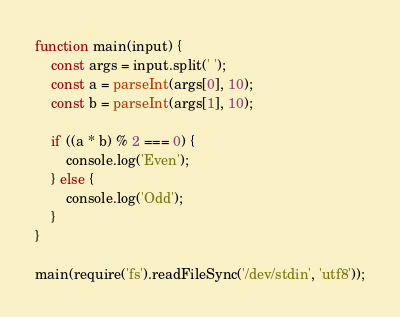Convert code to text. <code><loc_0><loc_0><loc_500><loc_500><_JavaScript_>function main(input) {
    const args = input.split(' ');
    const a = parseInt(args[0], 10);
    const b = parseInt(args[1], 10);

    if ((a * b) % 2 === 0) {
        console.log('Even');
    } else {
        console.log('Odd');
    }
}

main(require('fs').readFileSync('/dev/stdin', 'utf8'));</code> 